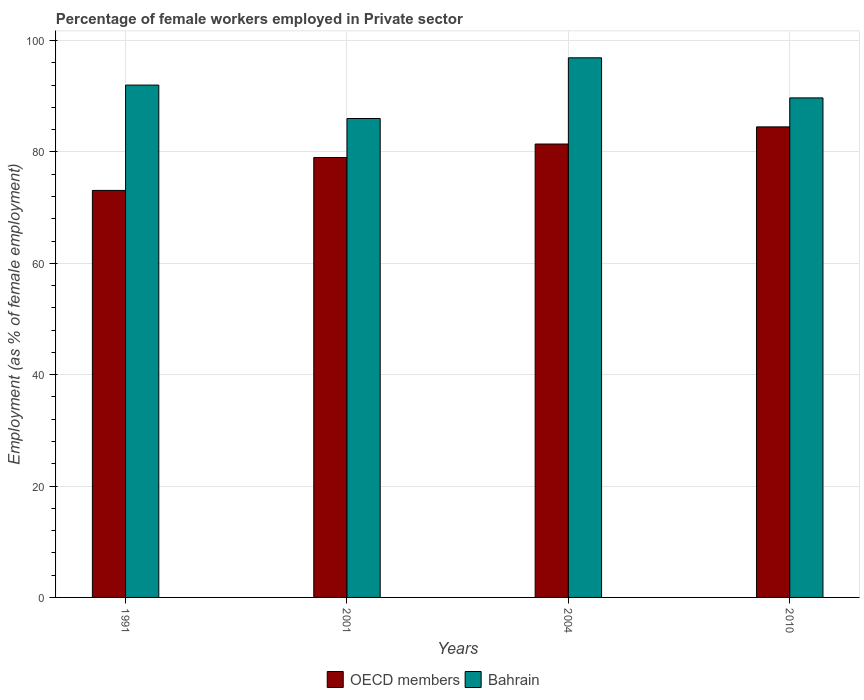How many different coloured bars are there?
Ensure brevity in your answer.  2. How many groups of bars are there?
Give a very brief answer. 4. How many bars are there on the 3rd tick from the left?
Offer a terse response. 2. What is the label of the 4th group of bars from the left?
Offer a very short reply. 2010. What is the percentage of females employed in Private sector in Bahrain in 1991?
Your answer should be very brief. 92. Across all years, what is the maximum percentage of females employed in Private sector in OECD members?
Keep it short and to the point. 84.5. In which year was the percentage of females employed in Private sector in OECD members maximum?
Your response must be concise. 2010. In which year was the percentage of females employed in Private sector in OECD members minimum?
Provide a succinct answer. 1991. What is the total percentage of females employed in Private sector in Bahrain in the graph?
Ensure brevity in your answer.  364.6. What is the difference between the percentage of females employed in Private sector in Bahrain in 2004 and that in 2010?
Ensure brevity in your answer.  7.2. What is the difference between the percentage of females employed in Private sector in Bahrain in 2001 and the percentage of females employed in Private sector in OECD members in 2004?
Provide a succinct answer. 4.58. What is the average percentage of females employed in Private sector in OECD members per year?
Provide a short and direct response. 79.5. In the year 2001, what is the difference between the percentage of females employed in Private sector in OECD members and percentage of females employed in Private sector in Bahrain?
Provide a succinct answer. -7. In how many years, is the percentage of females employed in Private sector in Bahrain greater than 68 %?
Give a very brief answer. 4. What is the ratio of the percentage of females employed in Private sector in OECD members in 1991 to that in 2010?
Provide a succinct answer. 0.86. What is the difference between the highest and the second highest percentage of females employed in Private sector in OECD members?
Provide a short and direct response. 3.08. What is the difference between the highest and the lowest percentage of females employed in Private sector in Bahrain?
Ensure brevity in your answer.  10.9. In how many years, is the percentage of females employed in Private sector in OECD members greater than the average percentage of females employed in Private sector in OECD members taken over all years?
Provide a short and direct response. 2. Is the sum of the percentage of females employed in Private sector in Bahrain in 2001 and 2004 greater than the maximum percentage of females employed in Private sector in OECD members across all years?
Keep it short and to the point. Yes. What does the 2nd bar from the left in 2001 represents?
Keep it short and to the point. Bahrain. Are the values on the major ticks of Y-axis written in scientific E-notation?
Give a very brief answer. No. Does the graph contain grids?
Offer a terse response. Yes. Where does the legend appear in the graph?
Give a very brief answer. Bottom center. How many legend labels are there?
Your answer should be very brief. 2. How are the legend labels stacked?
Your response must be concise. Horizontal. What is the title of the graph?
Offer a very short reply. Percentage of female workers employed in Private sector. What is the label or title of the X-axis?
Ensure brevity in your answer.  Years. What is the label or title of the Y-axis?
Provide a succinct answer. Employment (as % of female employment). What is the Employment (as % of female employment) in OECD members in 1991?
Keep it short and to the point. 73.09. What is the Employment (as % of female employment) in Bahrain in 1991?
Give a very brief answer. 92. What is the Employment (as % of female employment) of OECD members in 2001?
Make the answer very short. 79. What is the Employment (as % of female employment) in Bahrain in 2001?
Provide a short and direct response. 86. What is the Employment (as % of female employment) in OECD members in 2004?
Your answer should be very brief. 81.42. What is the Employment (as % of female employment) in Bahrain in 2004?
Provide a short and direct response. 96.9. What is the Employment (as % of female employment) of OECD members in 2010?
Your response must be concise. 84.5. What is the Employment (as % of female employment) of Bahrain in 2010?
Keep it short and to the point. 89.7. Across all years, what is the maximum Employment (as % of female employment) in OECD members?
Make the answer very short. 84.5. Across all years, what is the maximum Employment (as % of female employment) in Bahrain?
Make the answer very short. 96.9. Across all years, what is the minimum Employment (as % of female employment) of OECD members?
Your answer should be compact. 73.09. Across all years, what is the minimum Employment (as % of female employment) of Bahrain?
Your answer should be compact. 86. What is the total Employment (as % of female employment) in OECD members in the graph?
Offer a terse response. 318. What is the total Employment (as % of female employment) in Bahrain in the graph?
Provide a succinct answer. 364.6. What is the difference between the Employment (as % of female employment) of OECD members in 1991 and that in 2001?
Provide a short and direct response. -5.91. What is the difference between the Employment (as % of female employment) in Bahrain in 1991 and that in 2001?
Your answer should be compact. 6. What is the difference between the Employment (as % of female employment) in OECD members in 1991 and that in 2004?
Provide a short and direct response. -8.33. What is the difference between the Employment (as % of female employment) in OECD members in 1991 and that in 2010?
Give a very brief answer. -11.41. What is the difference between the Employment (as % of female employment) in Bahrain in 1991 and that in 2010?
Provide a succinct answer. 2.3. What is the difference between the Employment (as % of female employment) in OECD members in 2001 and that in 2004?
Ensure brevity in your answer.  -2.42. What is the difference between the Employment (as % of female employment) of Bahrain in 2001 and that in 2004?
Give a very brief answer. -10.9. What is the difference between the Employment (as % of female employment) of OECD members in 2001 and that in 2010?
Your response must be concise. -5.5. What is the difference between the Employment (as % of female employment) in OECD members in 2004 and that in 2010?
Provide a succinct answer. -3.08. What is the difference between the Employment (as % of female employment) of OECD members in 1991 and the Employment (as % of female employment) of Bahrain in 2001?
Keep it short and to the point. -12.91. What is the difference between the Employment (as % of female employment) of OECD members in 1991 and the Employment (as % of female employment) of Bahrain in 2004?
Provide a succinct answer. -23.81. What is the difference between the Employment (as % of female employment) of OECD members in 1991 and the Employment (as % of female employment) of Bahrain in 2010?
Ensure brevity in your answer.  -16.61. What is the difference between the Employment (as % of female employment) of OECD members in 2001 and the Employment (as % of female employment) of Bahrain in 2004?
Offer a terse response. -17.9. What is the difference between the Employment (as % of female employment) in OECD members in 2001 and the Employment (as % of female employment) in Bahrain in 2010?
Provide a succinct answer. -10.7. What is the difference between the Employment (as % of female employment) of OECD members in 2004 and the Employment (as % of female employment) of Bahrain in 2010?
Provide a succinct answer. -8.28. What is the average Employment (as % of female employment) in OECD members per year?
Provide a succinct answer. 79.5. What is the average Employment (as % of female employment) in Bahrain per year?
Provide a short and direct response. 91.15. In the year 1991, what is the difference between the Employment (as % of female employment) in OECD members and Employment (as % of female employment) in Bahrain?
Keep it short and to the point. -18.91. In the year 2001, what is the difference between the Employment (as % of female employment) of OECD members and Employment (as % of female employment) of Bahrain?
Offer a terse response. -7. In the year 2004, what is the difference between the Employment (as % of female employment) in OECD members and Employment (as % of female employment) in Bahrain?
Ensure brevity in your answer.  -15.48. In the year 2010, what is the difference between the Employment (as % of female employment) in OECD members and Employment (as % of female employment) in Bahrain?
Ensure brevity in your answer.  -5.2. What is the ratio of the Employment (as % of female employment) in OECD members in 1991 to that in 2001?
Make the answer very short. 0.93. What is the ratio of the Employment (as % of female employment) in Bahrain in 1991 to that in 2001?
Your response must be concise. 1.07. What is the ratio of the Employment (as % of female employment) of OECD members in 1991 to that in 2004?
Keep it short and to the point. 0.9. What is the ratio of the Employment (as % of female employment) in Bahrain in 1991 to that in 2004?
Your answer should be very brief. 0.95. What is the ratio of the Employment (as % of female employment) in OECD members in 1991 to that in 2010?
Provide a succinct answer. 0.86. What is the ratio of the Employment (as % of female employment) of Bahrain in 1991 to that in 2010?
Offer a very short reply. 1.03. What is the ratio of the Employment (as % of female employment) of OECD members in 2001 to that in 2004?
Provide a short and direct response. 0.97. What is the ratio of the Employment (as % of female employment) in Bahrain in 2001 to that in 2004?
Ensure brevity in your answer.  0.89. What is the ratio of the Employment (as % of female employment) in OECD members in 2001 to that in 2010?
Your response must be concise. 0.93. What is the ratio of the Employment (as % of female employment) of Bahrain in 2001 to that in 2010?
Make the answer very short. 0.96. What is the ratio of the Employment (as % of female employment) in OECD members in 2004 to that in 2010?
Make the answer very short. 0.96. What is the ratio of the Employment (as % of female employment) of Bahrain in 2004 to that in 2010?
Keep it short and to the point. 1.08. What is the difference between the highest and the second highest Employment (as % of female employment) in OECD members?
Keep it short and to the point. 3.08. What is the difference between the highest and the second highest Employment (as % of female employment) in Bahrain?
Ensure brevity in your answer.  4.9. What is the difference between the highest and the lowest Employment (as % of female employment) in OECD members?
Keep it short and to the point. 11.41. 